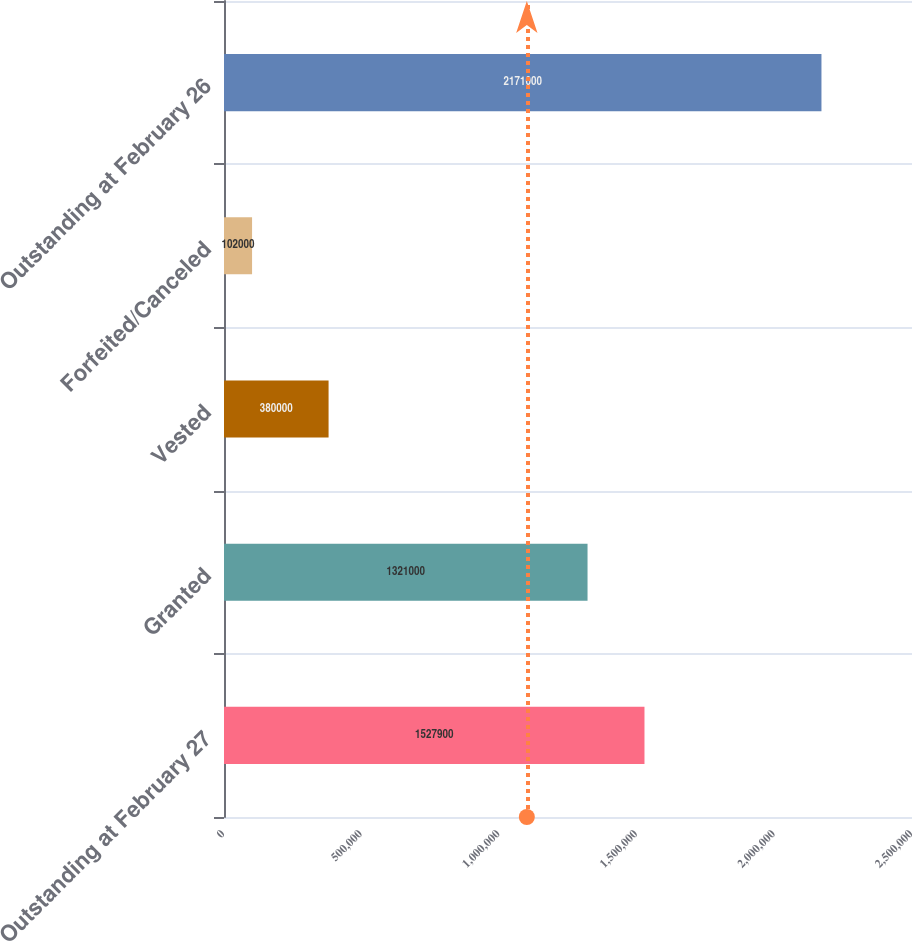Convert chart. <chart><loc_0><loc_0><loc_500><loc_500><bar_chart><fcel>Outstanding at February 27<fcel>Granted<fcel>Vested<fcel>Forfeited/Canceled<fcel>Outstanding at February 26<nl><fcel>1.5279e+06<fcel>1.321e+06<fcel>380000<fcel>102000<fcel>2.171e+06<nl></chart> 